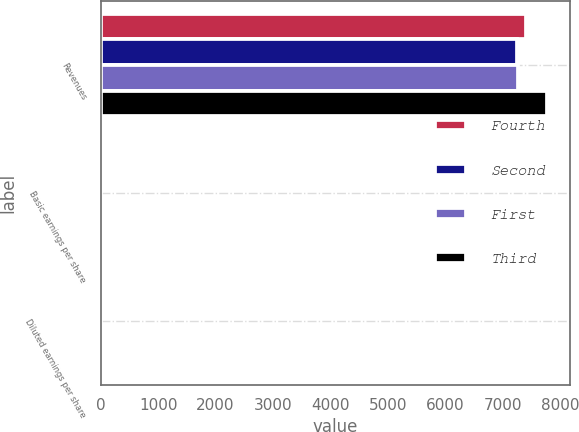Convert chart to OTSL. <chart><loc_0><loc_0><loc_500><loc_500><stacked_bar_chart><ecel><fcel>Revenues<fcel>Basic earnings per share<fcel>Diluted earnings per share<nl><fcel>Fourth<fcel>7406<fcel>0.54<fcel>0.52<nl><fcel>Second<fcel>7249<fcel>0.44<fcel>0.43<nl><fcel>First<fcel>7258<fcel>0.12<fcel>0.11<nl><fcel>Third<fcel>7769<fcel>4.43<fcel>4.25<nl></chart> 